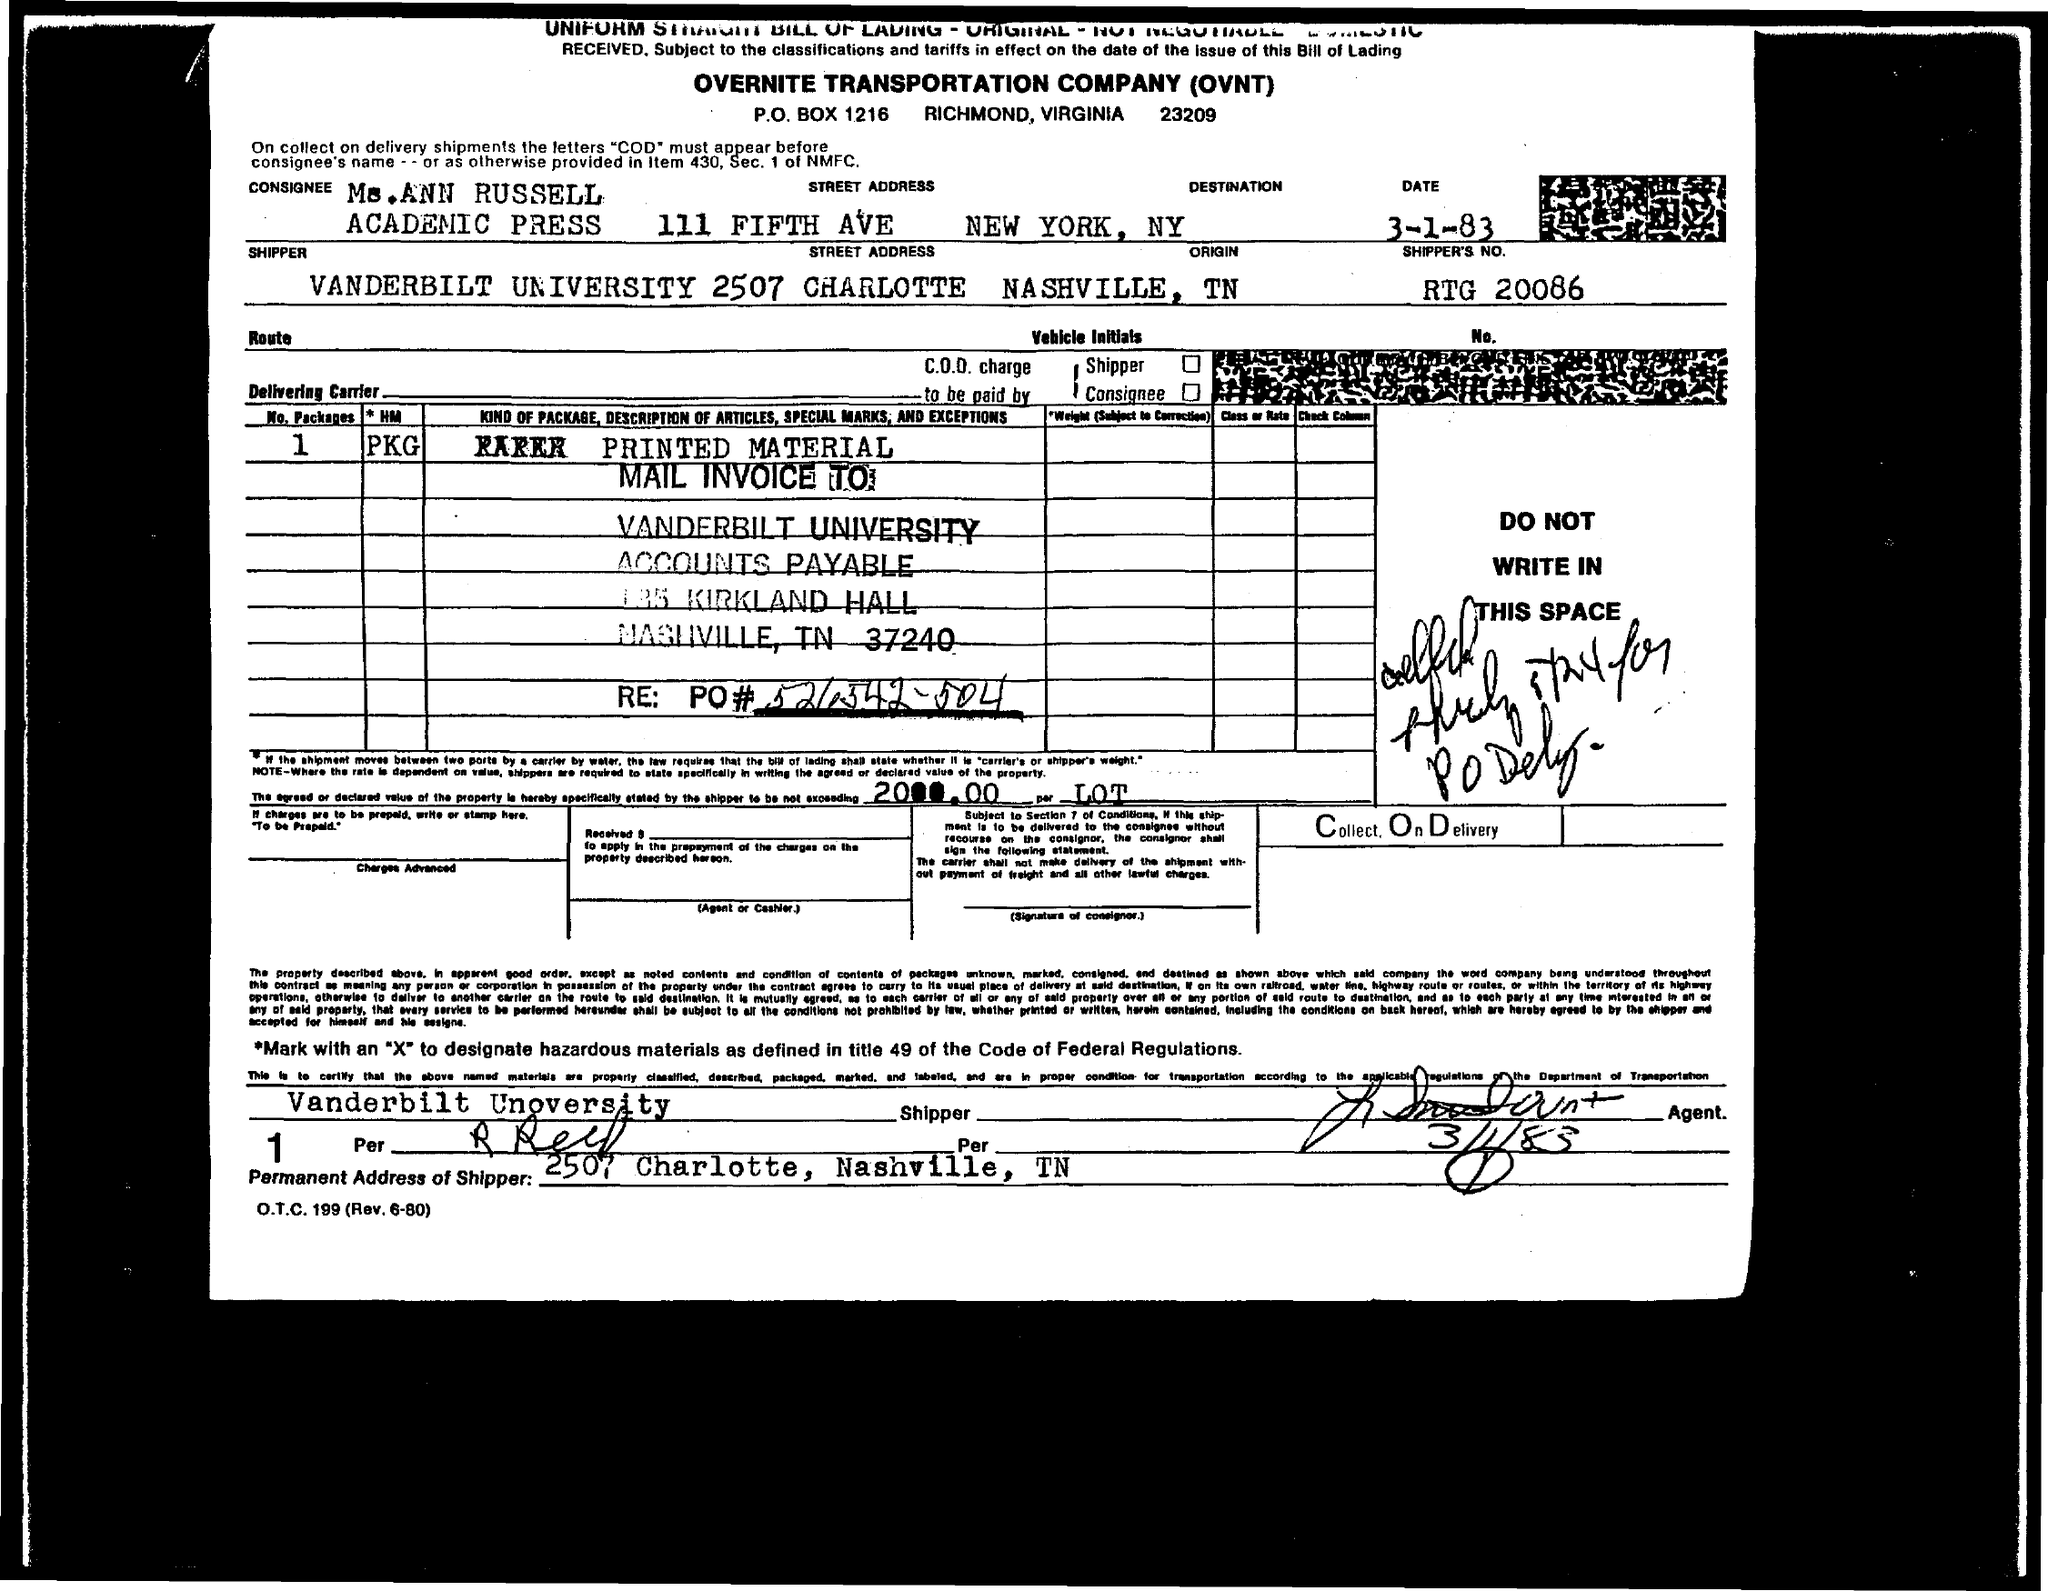Highlight a few significant elements in this photo. The shipper's number mentioned in the form is RTG 20086. The consignee name mentioned in the form is 'Ann Russell.' The fullform of OVNT is OVERNITE TRANSPORTATION COMPANY. The consignment's destination is New York, New York. The shipper for the consignment is Vanderbilt University. 